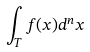Convert formula to latex. <formula><loc_0><loc_0><loc_500><loc_500>\int _ { T } f ( x ) d ^ { n } x</formula> 